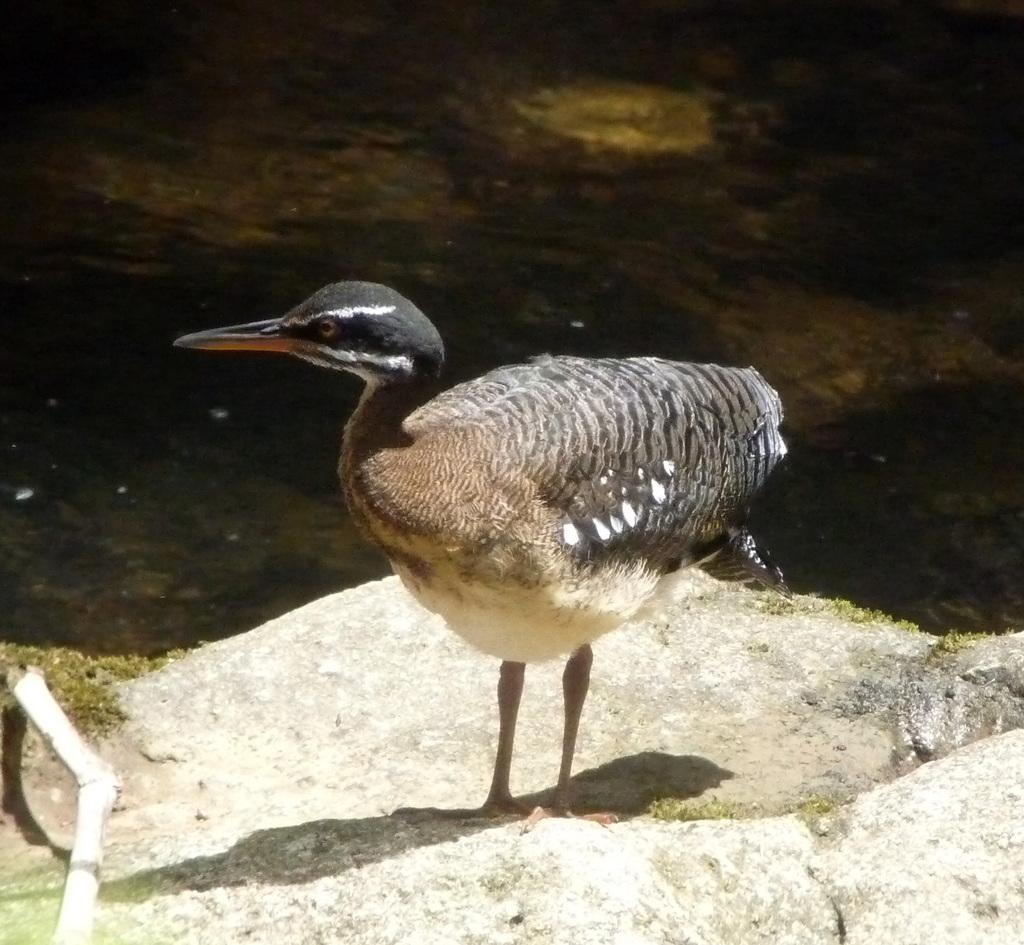What is the main subject in the foreground of the image? There is a bird in the foreground of the image. Where is the bird located? The bird is on the ground. What is the bird doing in the image? The bird is looking at someone. What type of stitch is the bird using to sew a button in the image? There is no stitch or button present in the image; it features a bird on the ground looking at someone. 